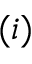Convert formula to latex. <formula><loc_0><loc_0><loc_500><loc_500>( i )</formula> 